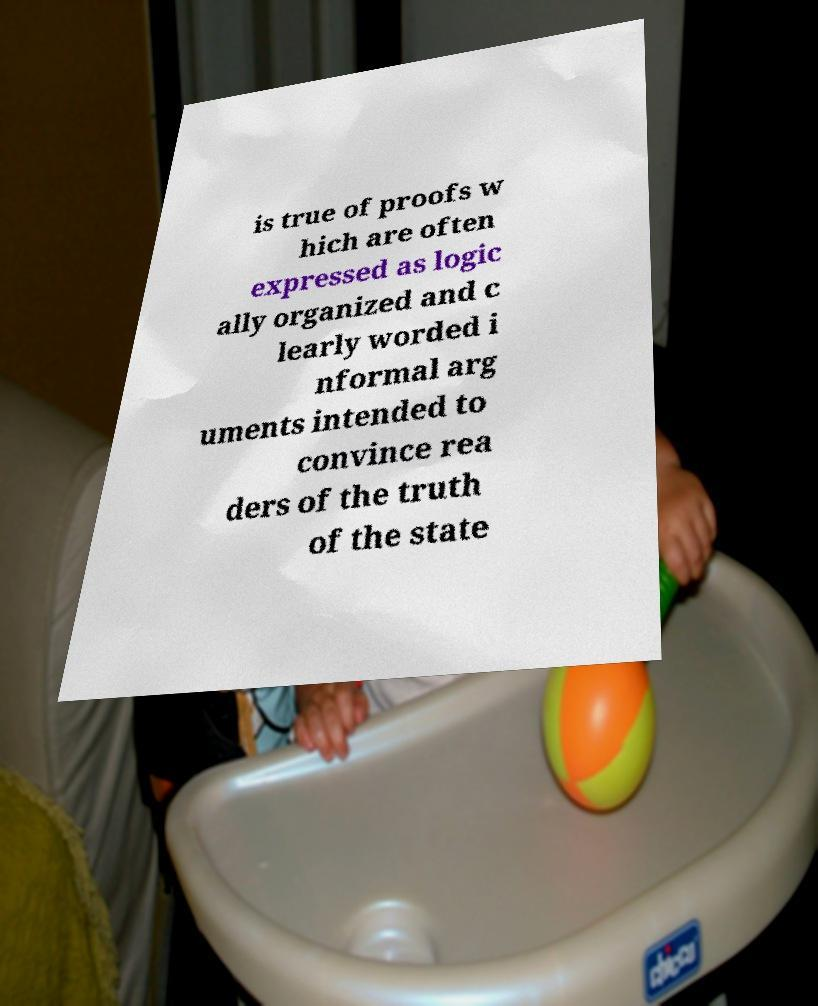What messages or text are displayed in this image? I need them in a readable, typed format. is true of proofs w hich are often expressed as logic ally organized and c learly worded i nformal arg uments intended to convince rea ders of the truth of the state 